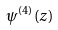Convert formula to latex. <formula><loc_0><loc_0><loc_500><loc_500>\psi ^ { ( 4 ) } ( z )</formula> 